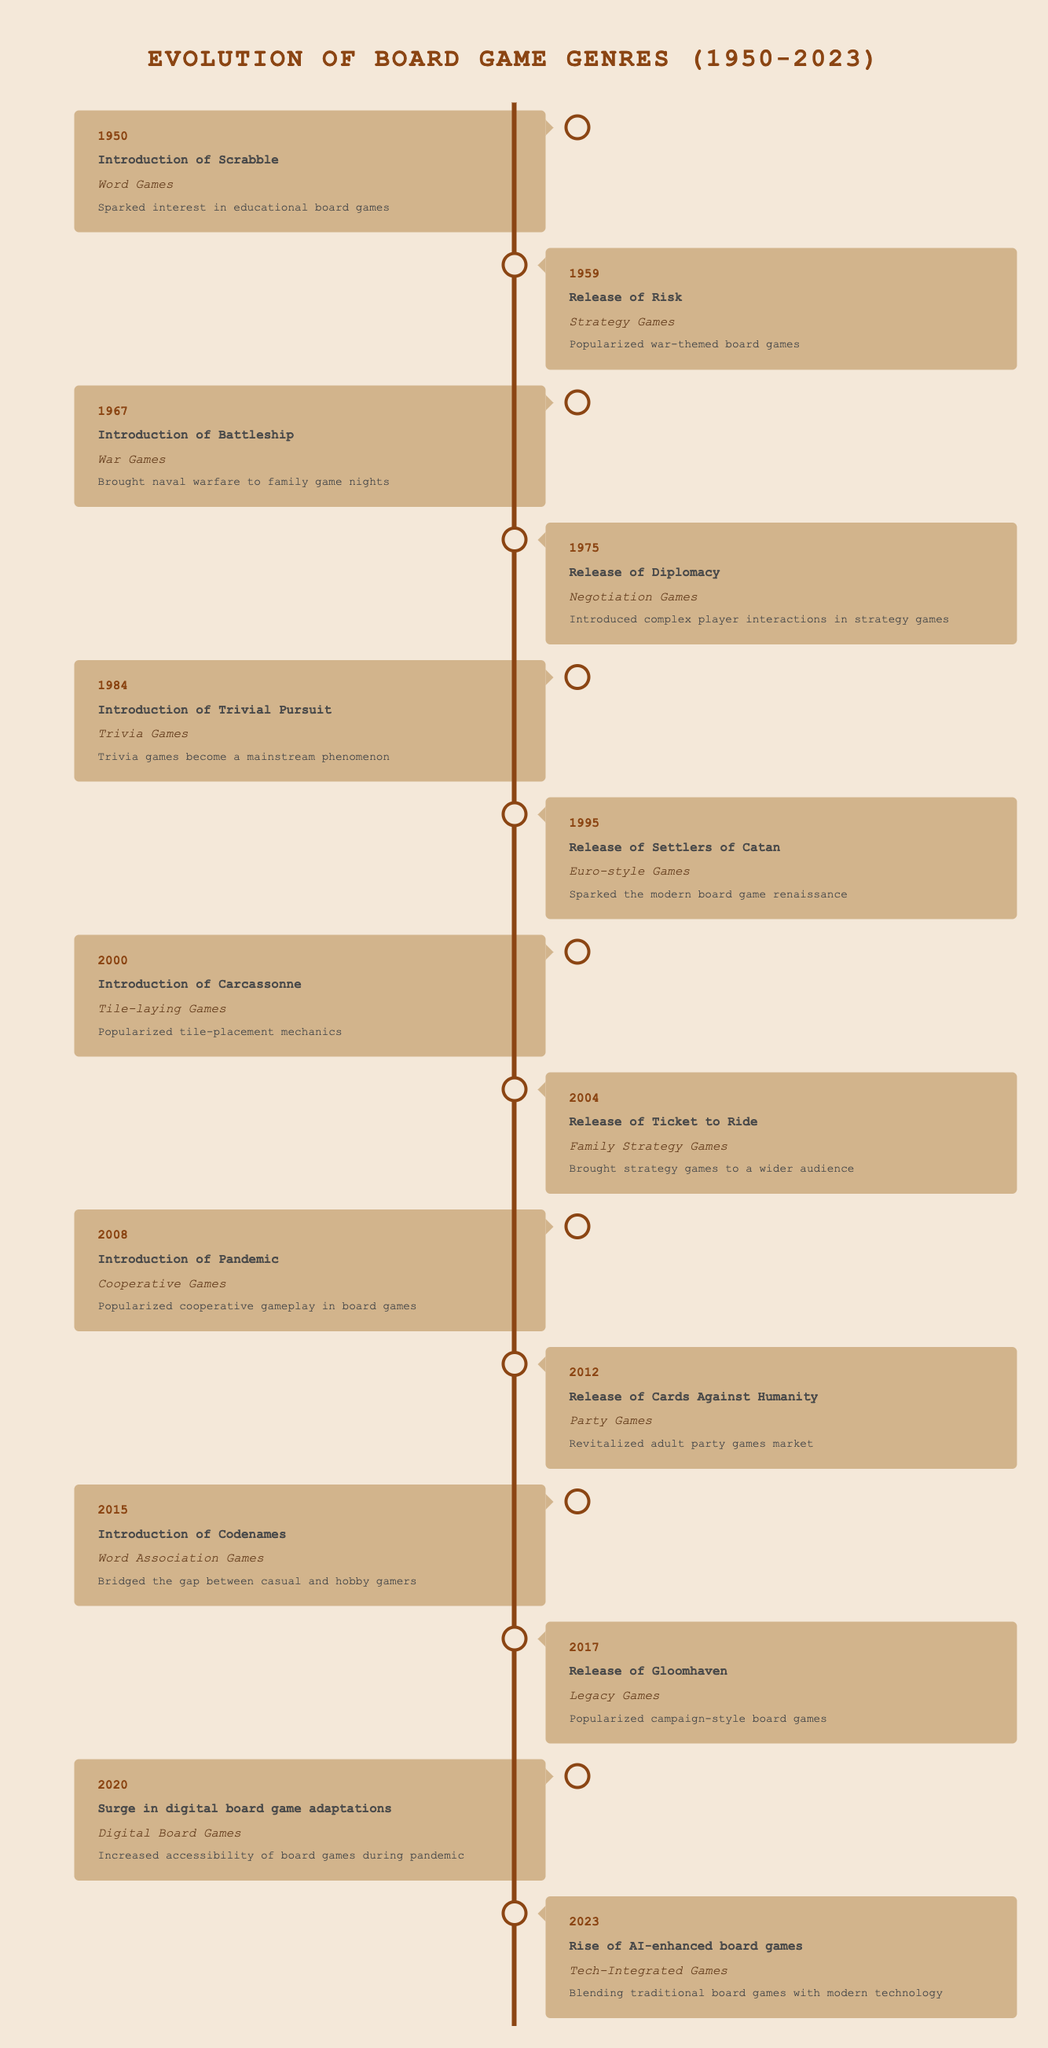What board game was introduced in 1950? Looking at the table, the event listed for the year 1950 is "Introduction of Scrabble."
Answer: Scrabble What genre does "Pandemic" belong to? The table lists "Pandemic" under the genre "Cooperative Games."
Answer: Cooperative Games Which game popularized war-themed board games? According to the 1959 entry in the table, "Risk" is mentioned as the game that popularized war-themed board games.
Answer: Risk What is the impact of "Settlers of Catan"? The table shows that "Settlers of Catan" sparked the modern board game renaissance, as stated in its impact description for the year 1995.
Answer: Sparked the modern board game renaissance How many years apart are the releases of "Risk" and "Codenames"? "Risk" was released in 1959 and "Codenames" was introduced in 2015. To find the difference in years, subtract 1959 from 2015, which gives 56 years apart.
Answer: 56 years Did "Trivial Pursuit" become a mainstream phenomenon? The impact of "Trivial Pursuit" listed in the 1984 entry states that it did become a mainstream phenomenon.
Answer: Yes What genre saw a surge in digital adaptations during the pandemic? The table specifies that the genre "Digital Board Games" saw a surge in adaptations during the pandemic in the year 2020.
Answer: Digital Board Games What two games introduced negotiation mechanics and cooperative mechanics respectively? "Diplomacy" introduced negotiation mechanics in 1975 and "Pandemic" introduced cooperative mechanics in 2008, as per the impact statements in the table.
Answer: Diplomacy and Pandemic How many genres saw their first introduction after the year 2000? The table shows that three genres were introduced after the year 2000: Tile-laying Games (2000), Cooperative Games (2008), and Family Strategy Games (2004). Thus, the total count of unique genres introduced after 2000 is three.
Answer: 3 genres 